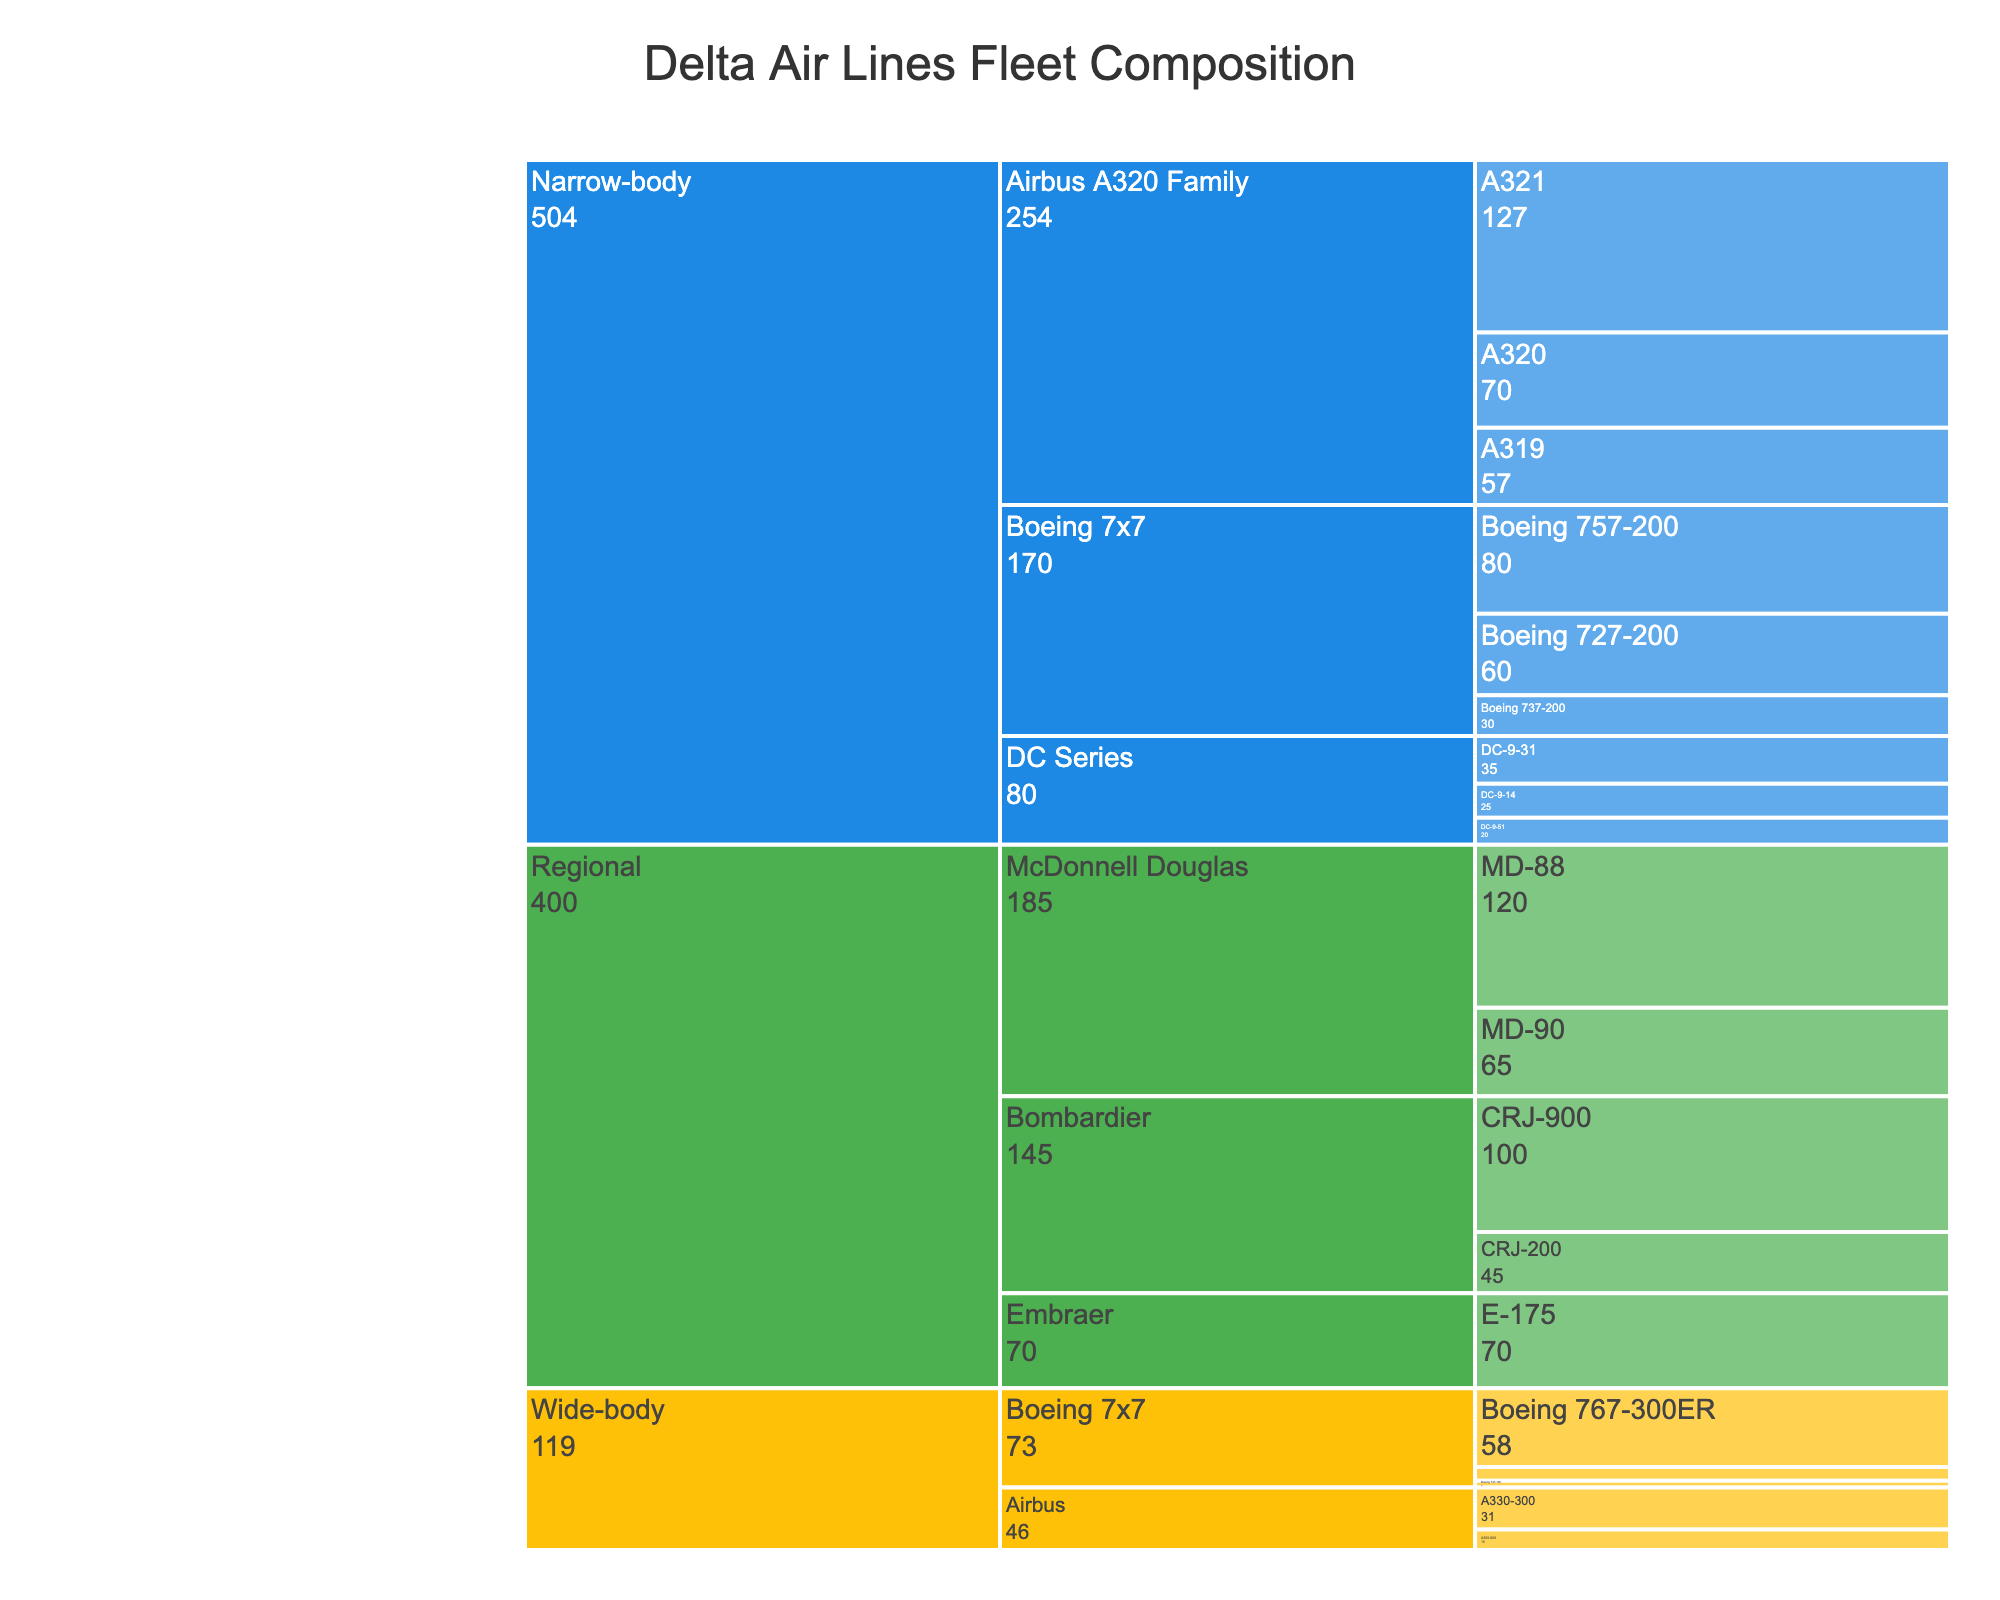what is the title of the chart? The title of the chart is generally found at the top of the chart. From the information provided, the title of the icicle chart is 'Delta Air Lines Fleet Composition'.
Answer: Delta Air Lines Fleet Composition what category has the most aircraft models? To determine this, look at the number of leaves directly under each main category (Narrow-body, Wide-body, Regional). The Narrow-body category has the most models.
Answer: Narrow-body how many Boeing 757-200 aircraft are there? Under the Narrow-body category, find the Boeing 7x7 subcategory and look for the count beside the Boeing 757-200 model. The count is 80.
Answer: 80 which aircraft model has the highest count? Scan through the data values for each aircraft model in the chart. The Airbus A321 under the Narrow-body category has the highest count at 127.
Answer: Airbus A321 compare the total counts of aircraft in Narrow-body and Wide-body categories Sum the counts of aircraft for each model under Narrow-body and Wide-body categories and compare the sums. Narrow-body: 474 (25+35+20+60+30+80+57+70+127), Wide-body: 119 (5+58+10+31+15). Narrow-body has more aircraft.
Answer: Narrow-body has more aircraft how many subcategories are in the Regional category? Look under the Regional category and count the different subsections (McDonnell Douglas, Bombardier, Embraer). There are 3 subcategories.
Answer: 3 what is the difference in count between the DC-9-31 and the DC-9-51 aircraft? From the Narrow-body category under DC Series, subtract the count of DC-9-51 (20) from DC-9-31 (35). The difference is 15.
Answer: 15 which category has the least number of total aircraft? Sum the number of aircraft in each main category, then identify the smallest amount. Regional: 400 (120+65+45+100+70). Regional has the least.
Answer: Regional compare the counts of Airbus aircraft models in Narrow-body and Wide-body categories For Narrow-body, sum the counts: A319 (57) + A320 (70) + A321 (127) = 254. For Wide-body, sum the counts: A330-300 (31) + A350-900 (15) = 46. Narrow-body has more Airbus aircraft.
Answer: Narrow-body has more Airbus aircraft how many aircraft in the Regional category are made by Bombardier? Look under the Regional category and sum the counts for Bombardier models: CRJ-200 (45) + CRJ-900 (100) = 145.
Answer: 145 